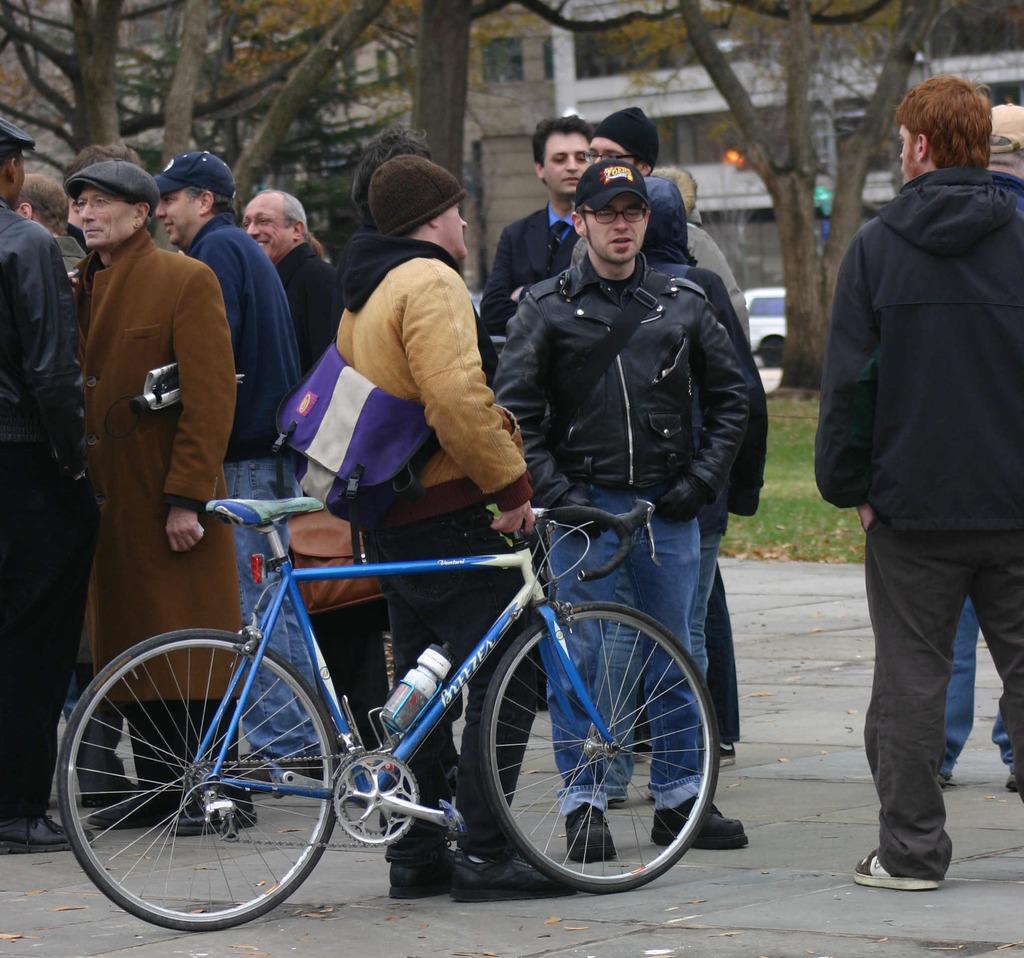Could you give a brief overview of what you see in this image? In this image I see a man who is holding the cycle and there are many people are standing on the path. In the background I see the trees, a car and the buildings. 